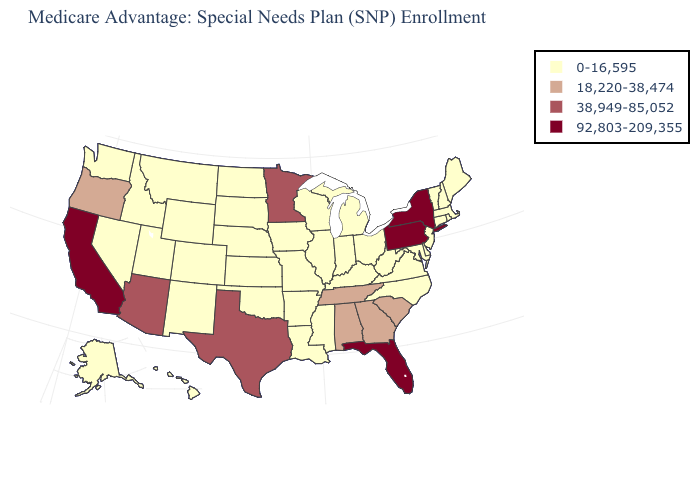Does California have the highest value in the West?
Write a very short answer. Yes. What is the highest value in the USA?
Give a very brief answer. 92,803-209,355. Name the states that have a value in the range 18,220-38,474?
Concise answer only. Alabama, Georgia, Oregon, South Carolina, Tennessee. Does Arkansas have the lowest value in the USA?
Keep it brief. Yes. What is the value of Maine?
Concise answer only. 0-16,595. Does the first symbol in the legend represent the smallest category?
Write a very short answer. Yes. Name the states that have a value in the range 0-16,595?
Concise answer only. Alaska, Arkansas, Colorado, Connecticut, Delaware, Hawaii, Iowa, Idaho, Illinois, Indiana, Kansas, Kentucky, Louisiana, Massachusetts, Maryland, Maine, Michigan, Missouri, Mississippi, Montana, North Carolina, North Dakota, Nebraska, New Hampshire, New Jersey, New Mexico, Nevada, Ohio, Oklahoma, Rhode Island, South Dakota, Utah, Virginia, Vermont, Washington, Wisconsin, West Virginia, Wyoming. Among the states that border Alabama , which have the highest value?
Answer briefly. Florida. Does Vermont have the highest value in the Northeast?
Keep it brief. No. How many symbols are there in the legend?
Give a very brief answer. 4. Name the states that have a value in the range 38,949-85,052?
Answer briefly. Arizona, Minnesota, Texas. Which states have the highest value in the USA?
Concise answer only. California, Florida, New York, Pennsylvania. Does Rhode Island have the lowest value in the Northeast?
Quick response, please. Yes. Does the first symbol in the legend represent the smallest category?
Give a very brief answer. Yes. Name the states that have a value in the range 18,220-38,474?
Quick response, please. Alabama, Georgia, Oregon, South Carolina, Tennessee. 